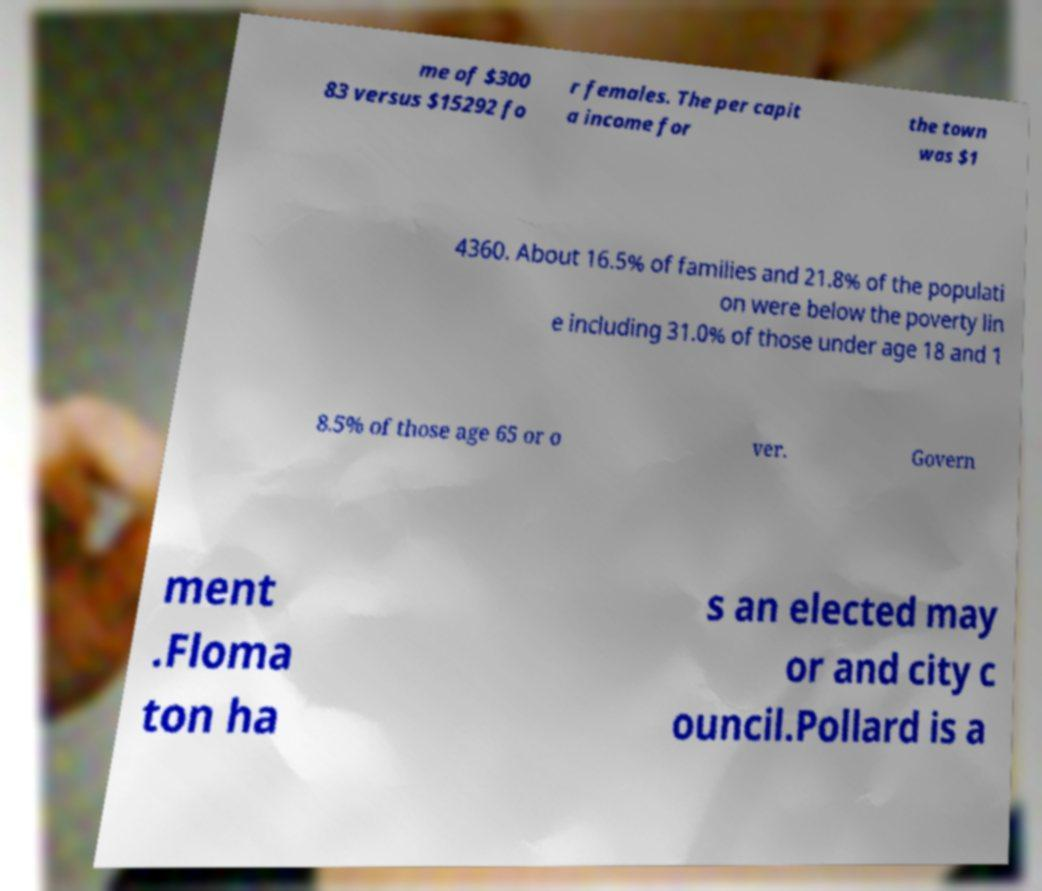Please read and relay the text visible in this image. What does it say? me of $300 83 versus $15292 fo r females. The per capit a income for the town was $1 4360. About 16.5% of families and 21.8% of the populati on were below the poverty lin e including 31.0% of those under age 18 and 1 8.5% of those age 65 or o ver. Govern ment .Floma ton ha s an elected may or and city c ouncil.Pollard is a 